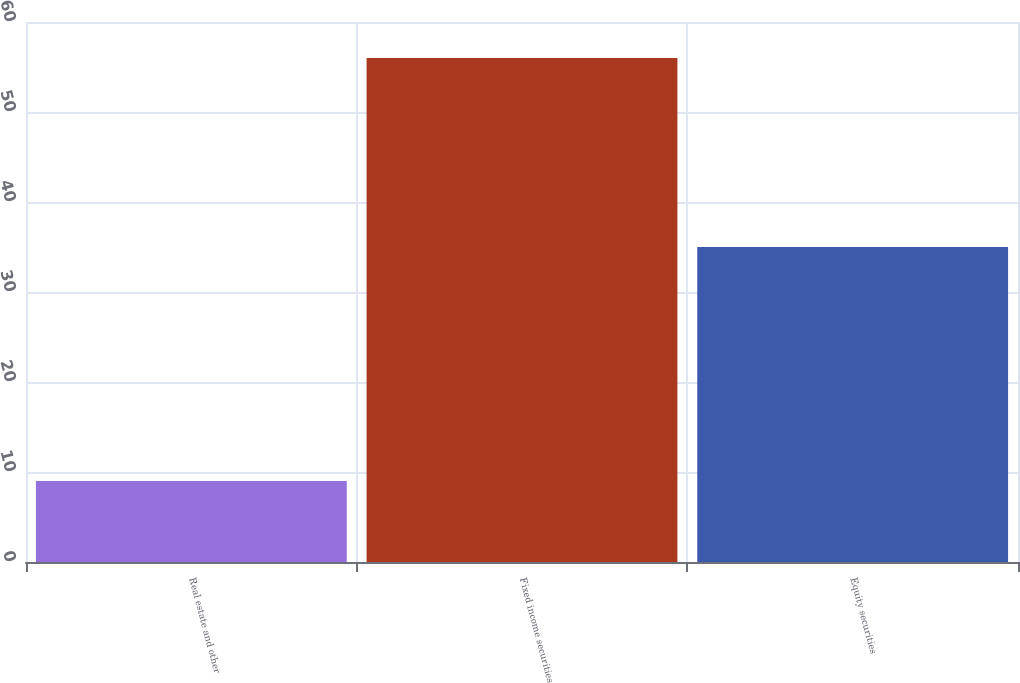<chart> <loc_0><loc_0><loc_500><loc_500><bar_chart><fcel>Real estate and other<fcel>Fixed income securities<fcel>Equity securities<nl><fcel>9<fcel>56<fcel>35<nl></chart> 